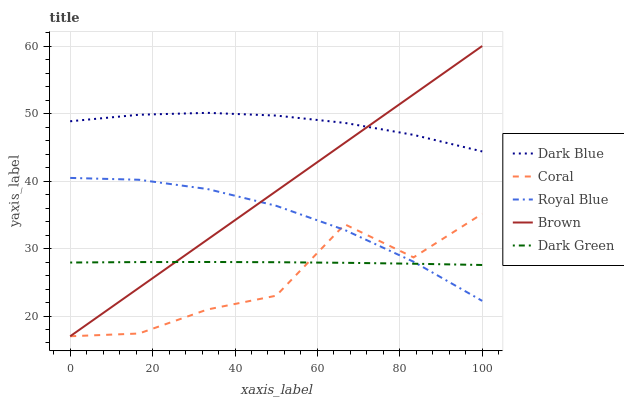Does Coral have the minimum area under the curve?
Answer yes or no. Yes. Does Dark Blue have the maximum area under the curve?
Answer yes or no. Yes. Does Dark Green have the minimum area under the curve?
Answer yes or no. No. Does Dark Green have the maximum area under the curve?
Answer yes or no. No. Is Brown the smoothest?
Answer yes or no. Yes. Is Coral the roughest?
Answer yes or no. Yes. Is Dark Green the smoothest?
Answer yes or no. No. Is Dark Green the roughest?
Answer yes or no. No. Does Coral have the lowest value?
Answer yes or no. Yes. Does Dark Green have the lowest value?
Answer yes or no. No. Does Brown have the highest value?
Answer yes or no. Yes. Does Coral have the highest value?
Answer yes or no. No. Is Dark Green less than Dark Blue?
Answer yes or no. Yes. Is Dark Blue greater than Dark Green?
Answer yes or no. Yes. Does Royal Blue intersect Coral?
Answer yes or no. Yes. Is Royal Blue less than Coral?
Answer yes or no. No. Is Royal Blue greater than Coral?
Answer yes or no. No. Does Dark Green intersect Dark Blue?
Answer yes or no. No. 